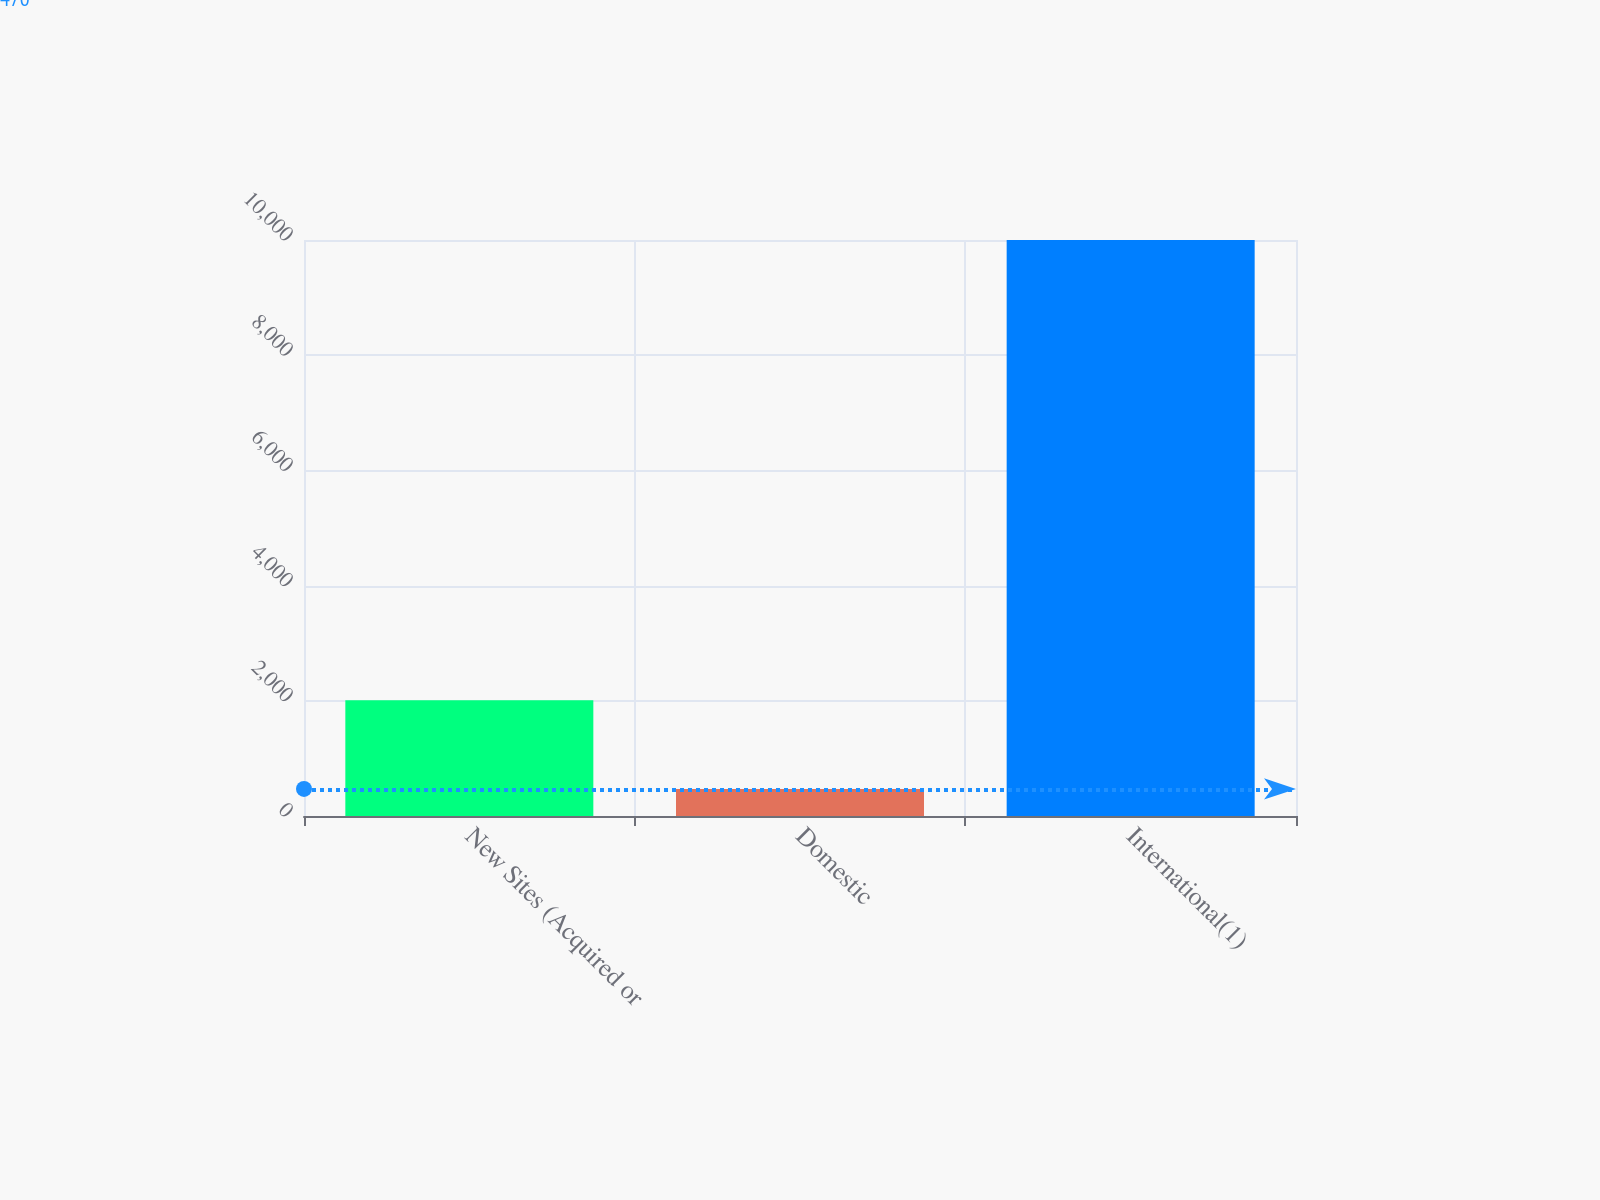<chart> <loc_0><loc_0><loc_500><loc_500><bar_chart><fcel>New Sites (Acquired or<fcel>Domestic<fcel>International(1)<nl><fcel>2011<fcel>470<fcel>10000<nl></chart> 